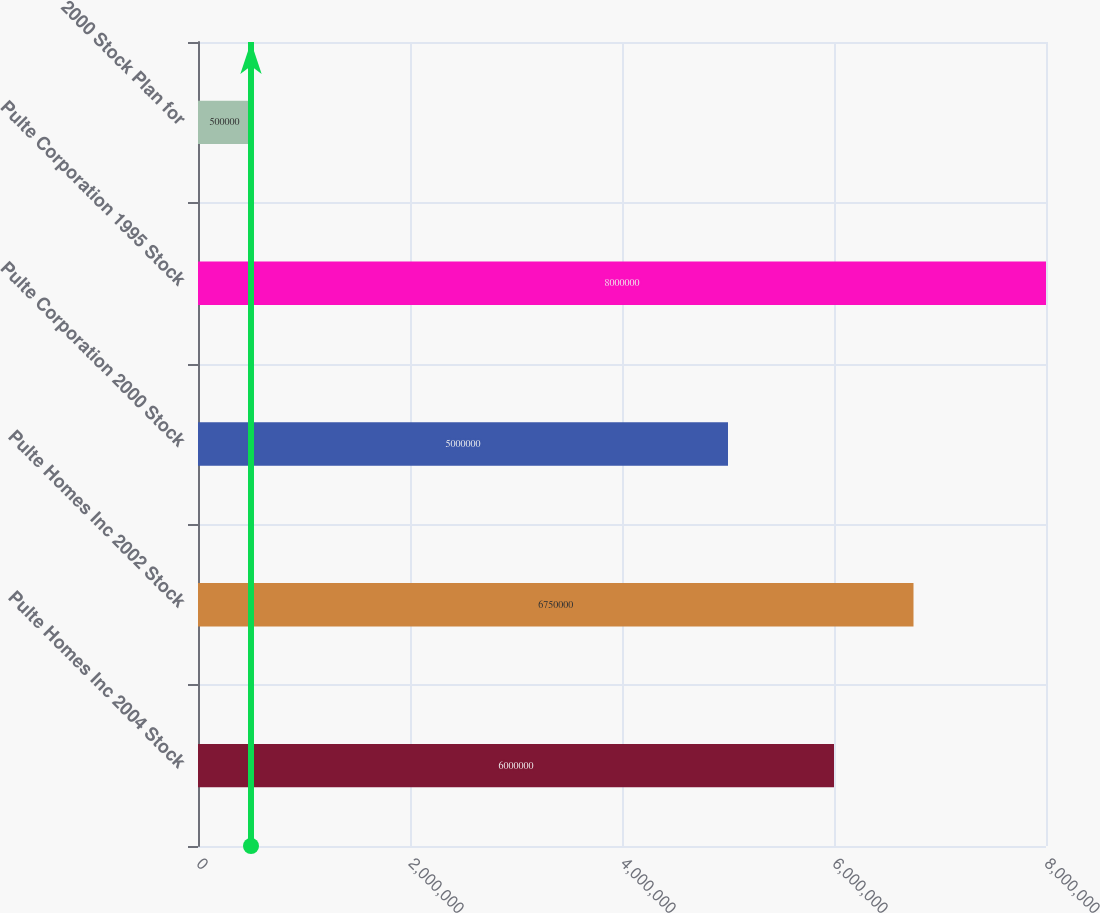Convert chart. <chart><loc_0><loc_0><loc_500><loc_500><bar_chart><fcel>Pulte Homes Inc 2004 Stock<fcel>Pulte Homes Inc 2002 Stock<fcel>Pulte Corporation 2000 Stock<fcel>Pulte Corporation 1995 Stock<fcel>2000 Stock Plan for<nl><fcel>6e+06<fcel>6.75e+06<fcel>5e+06<fcel>8e+06<fcel>500000<nl></chart> 